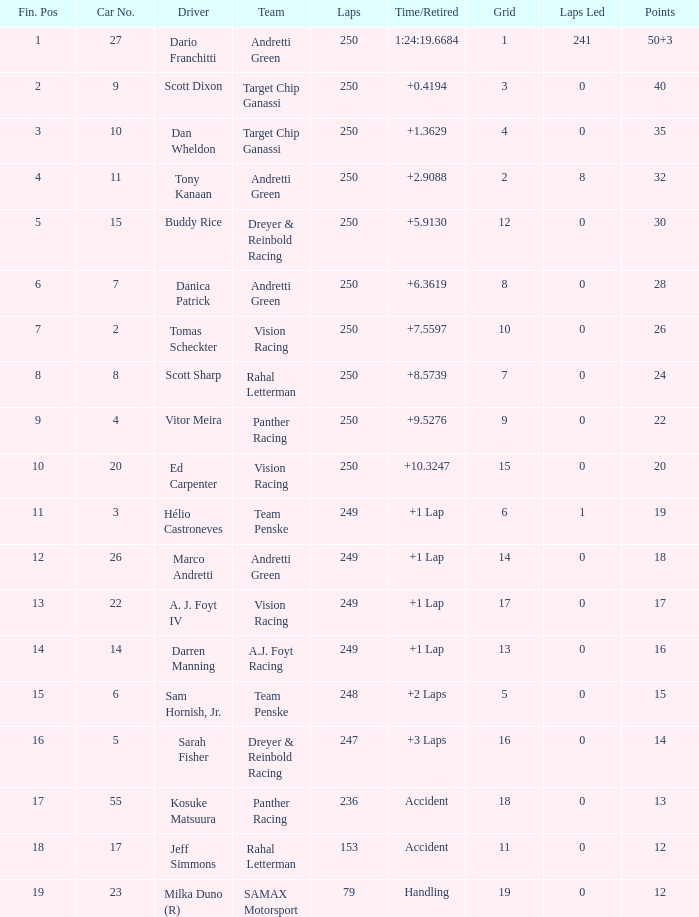Name the least grid for 17 points  17.0. 